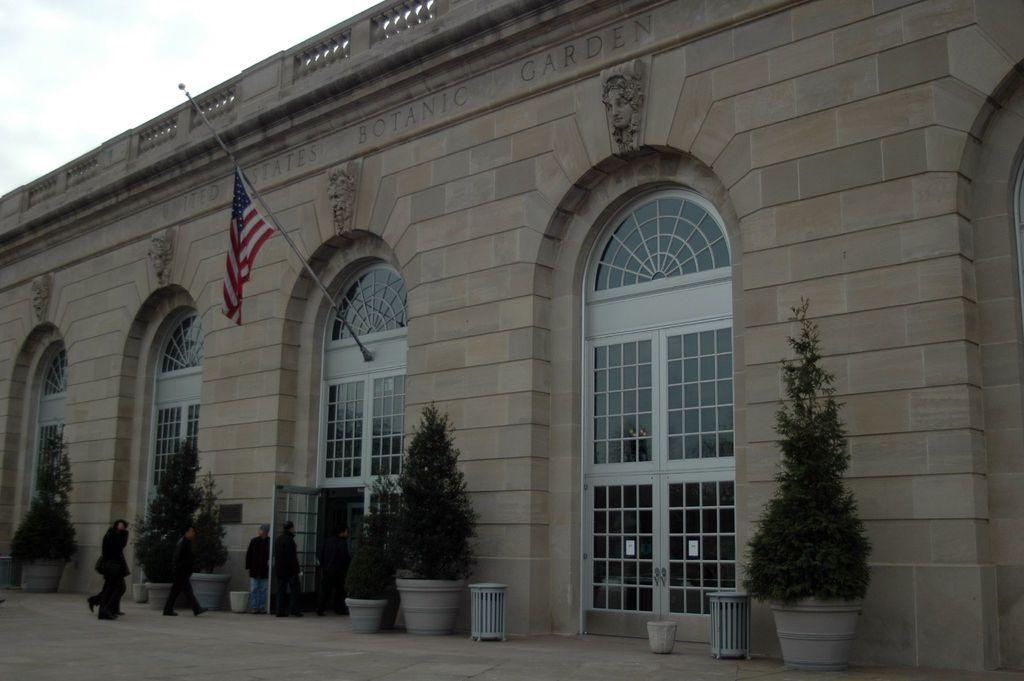What is the main subject in the center of the image? There is a building in the center of the image. What features can be observed on the building? The building has doors. What is located near the building? There is a flag near the building. What can be seen in the foreground of the image? In the foreground, there are plants and a dustbin. Are there any people visible in the image? Yes, people are visible in the foreground. What type of surface is present in the foreground? There is a pavement in the foreground. How would you describe the weather based on the image? The sky is cloudy in the image. How many boats are docked near the building in the image? There are no boats visible in the image; it features a building with a flag, foreground plants and a dustbin, and people on a pavement. What type of business is conducted in the building shown in the image? The image does not provide any information about the type of business conducted in the building. 